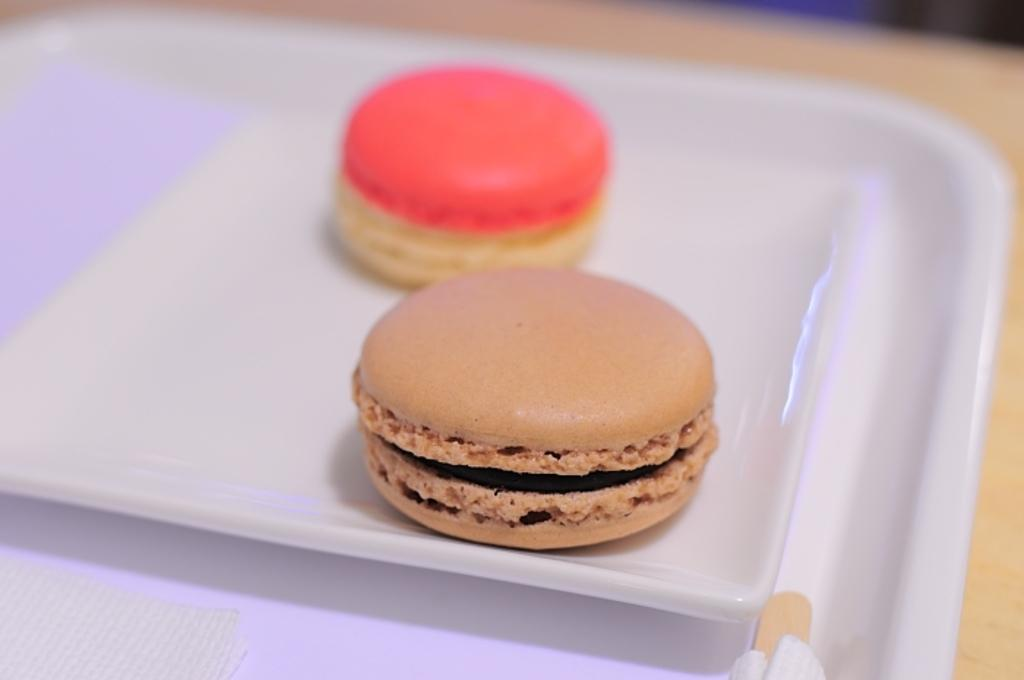What type of food can be seen in the image? There are biscuits in the image. How are the biscuits arranged in the image? The biscuits are in a plate. Where is the plate with biscuits located? The plate with biscuits is placed on a table. What type of vegetable is being added to the biscuits in the image? There is no vegetable being added to the biscuits in the image, as the facts only mention biscuits in a plate. 